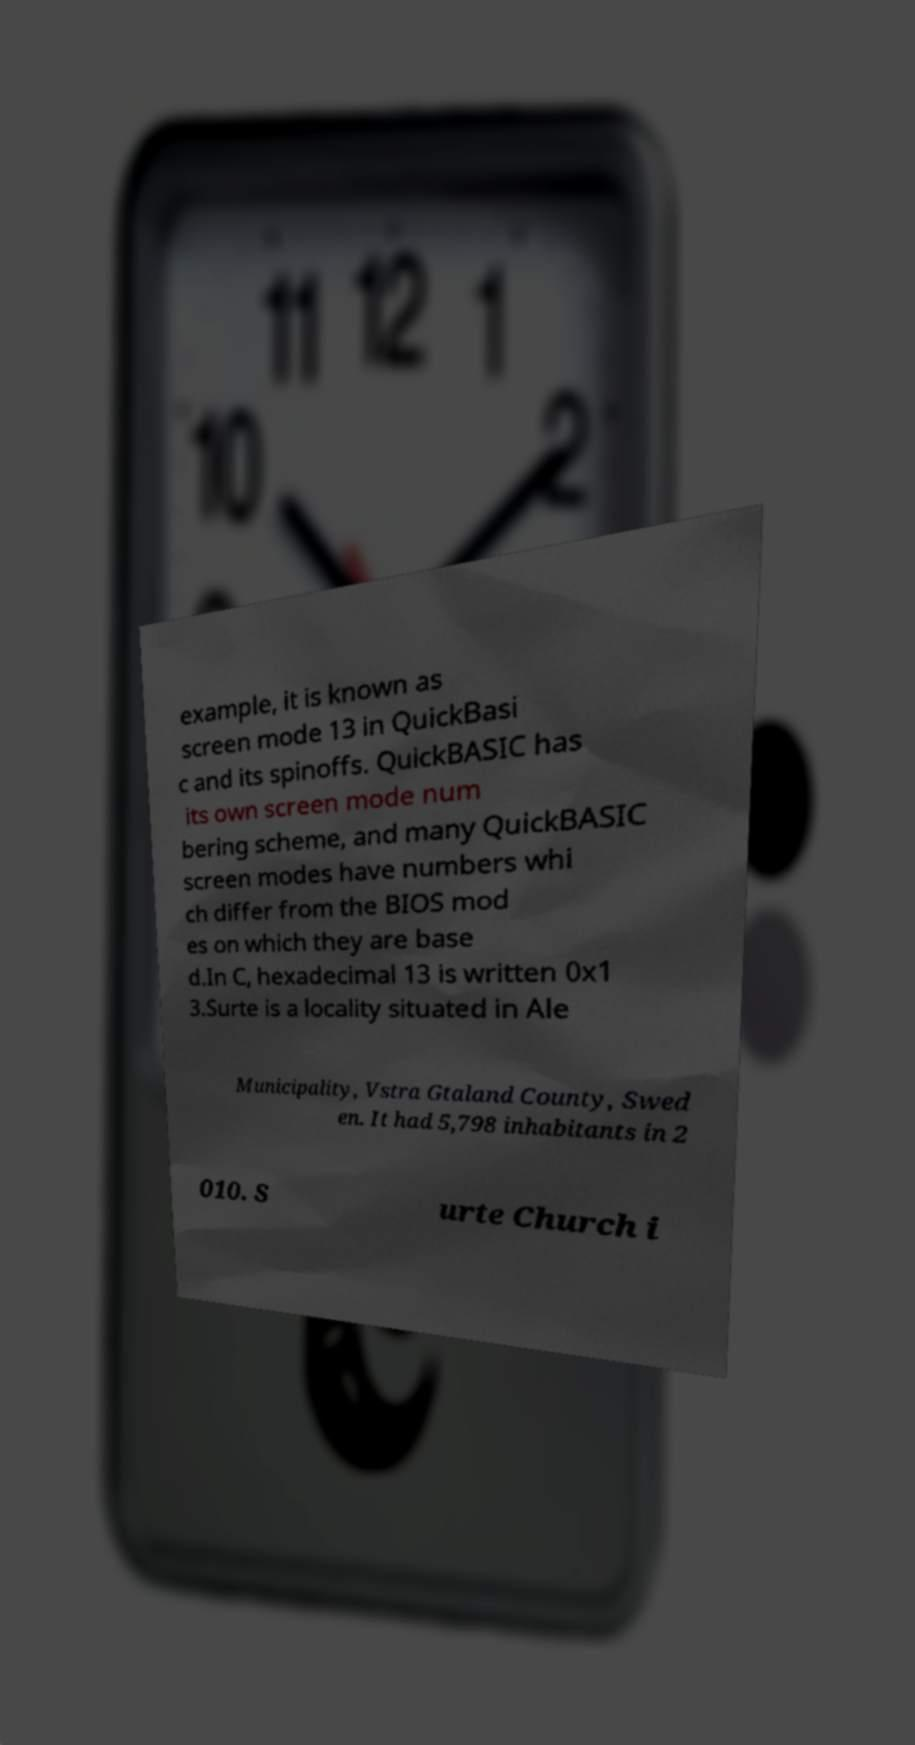Can you accurately transcribe the text from the provided image for me? example, it is known as screen mode 13 in QuickBasi c and its spinoffs. QuickBASIC has its own screen mode num bering scheme, and many QuickBASIC screen modes have numbers whi ch differ from the BIOS mod es on which they are base d.In C, hexadecimal 13 is written 0x1 3.Surte is a locality situated in Ale Municipality, Vstra Gtaland County, Swed en. It had 5,798 inhabitants in 2 010. S urte Church i 